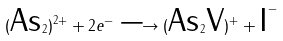Convert formula to latex. <formula><loc_0><loc_0><loc_500><loc_500>( \text {As} _ { 2 } ) ^ { 2 + } + 2 e ^ { - } \longrightarrow ( \text {As} _ { 2 } \text {V} ) ^ { + } + \text {I} ^ { - }</formula> 